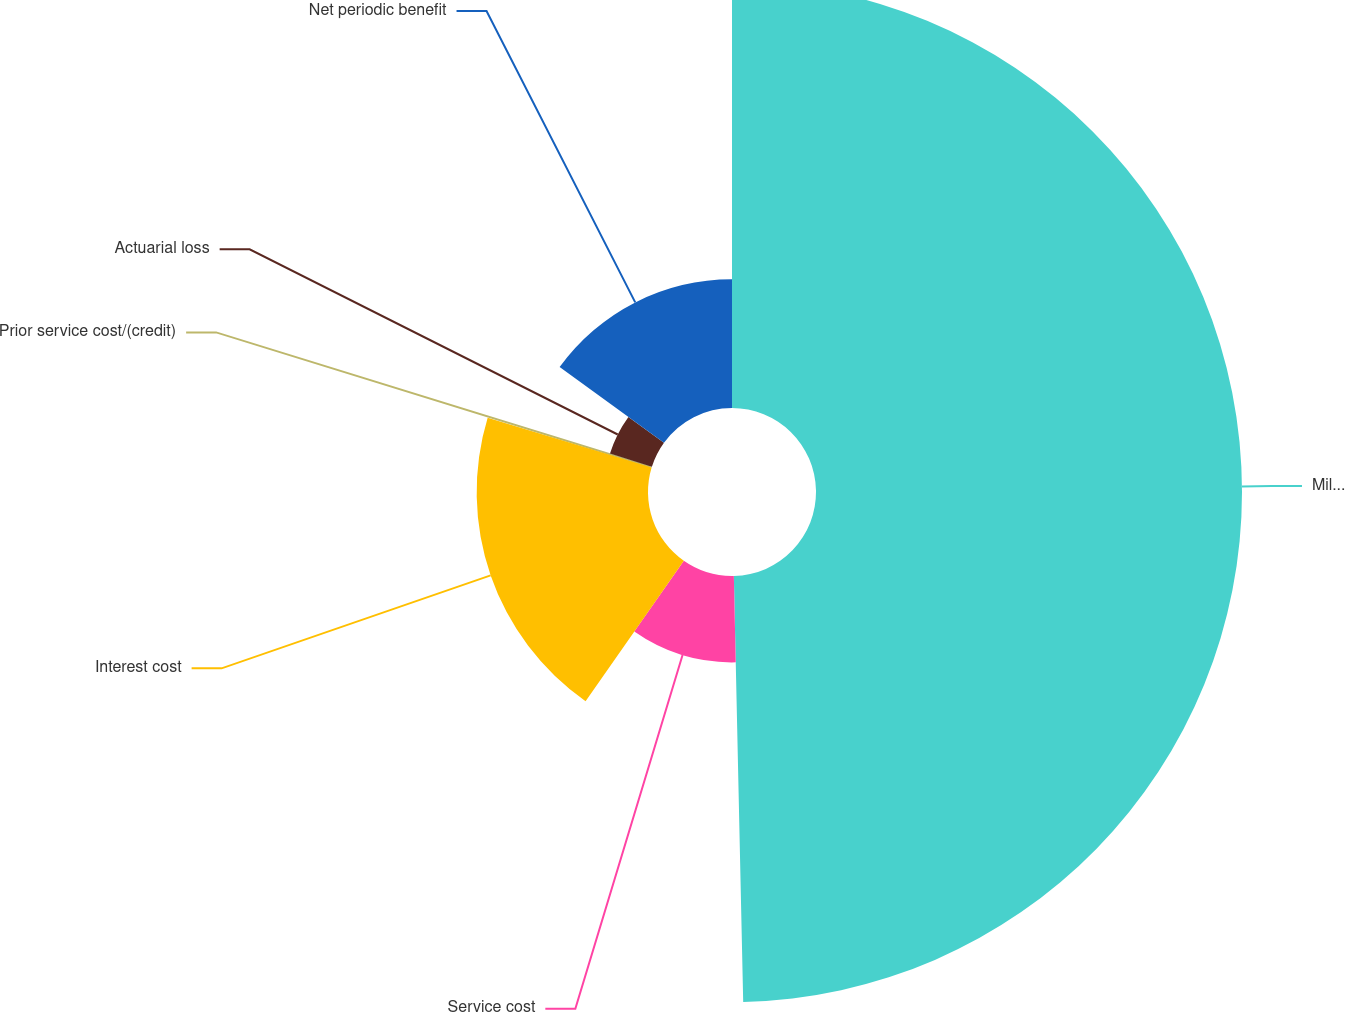<chart> <loc_0><loc_0><loc_500><loc_500><pie_chart><fcel>Millions of Dollars<fcel>Service cost<fcel>Interest cost<fcel>Prior service cost/(credit)<fcel>Actuarial loss<fcel>Net periodic benefit<nl><fcel>49.65%<fcel>10.07%<fcel>19.97%<fcel>0.17%<fcel>5.12%<fcel>15.02%<nl></chart> 